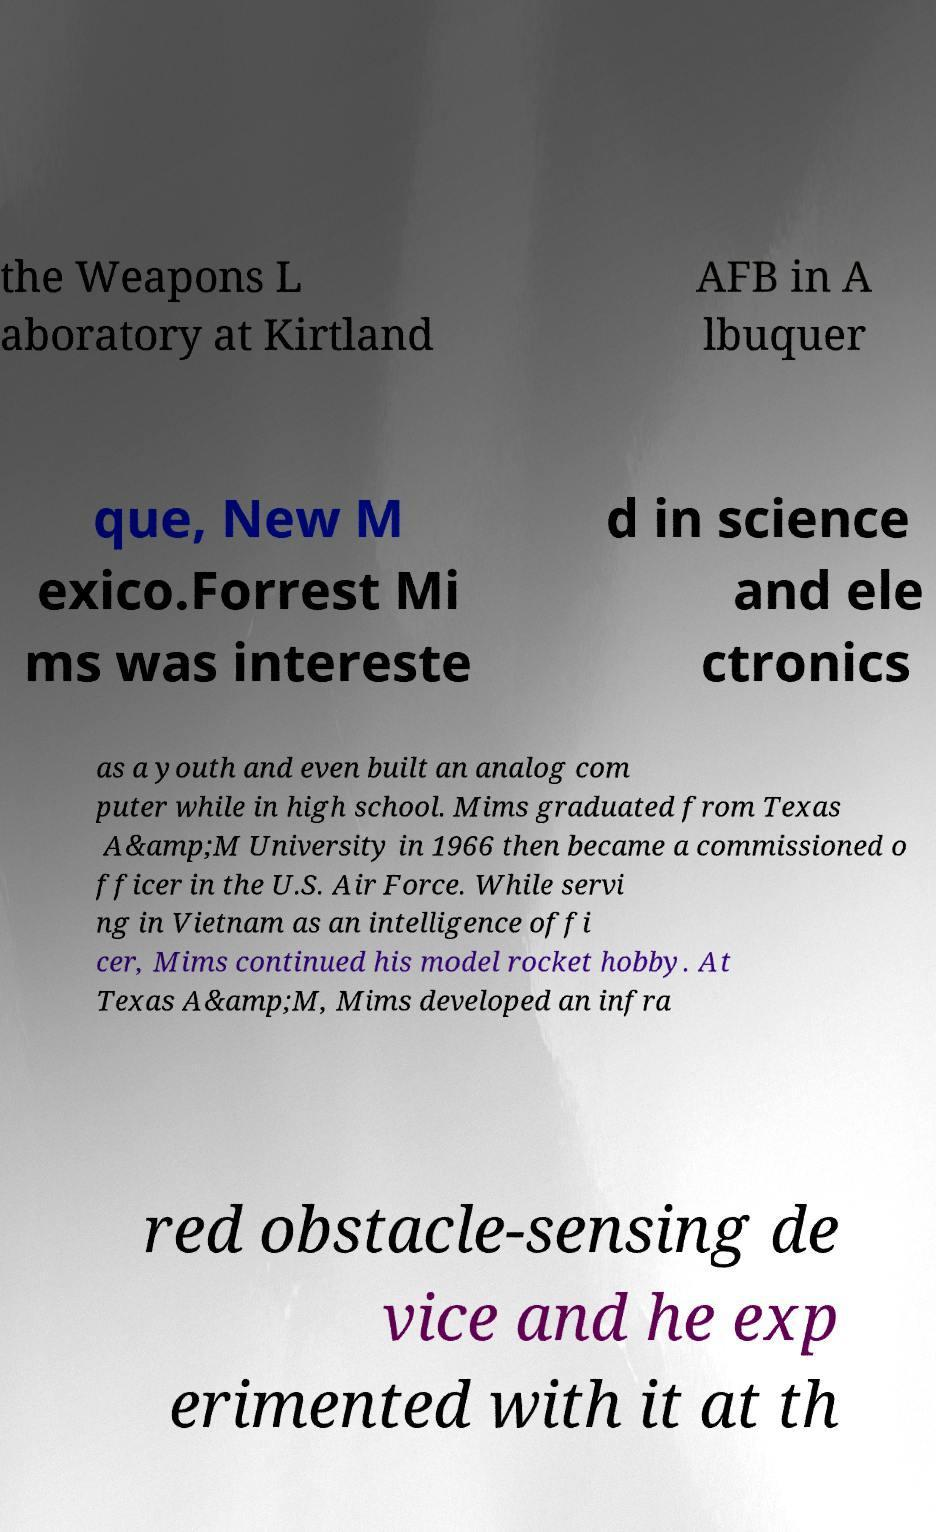Can you read and provide the text displayed in the image?This photo seems to have some interesting text. Can you extract and type it out for me? the Weapons L aboratory at Kirtland AFB in A lbuquer que, New M exico.Forrest Mi ms was intereste d in science and ele ctronics as a youth and even built an analog com puter while in high school. Mims graduated from Texas A&amp;M University in 1966 then became a commissioned o fficer in the U.S. Air Force. While servi ng in Vietnam as an intelligence offi cer, Mims continued his model rocket hobby. At Texas A&amp;M, Mims developed an infra red obstacle-sensing de vice and he exp erimented with it at th 